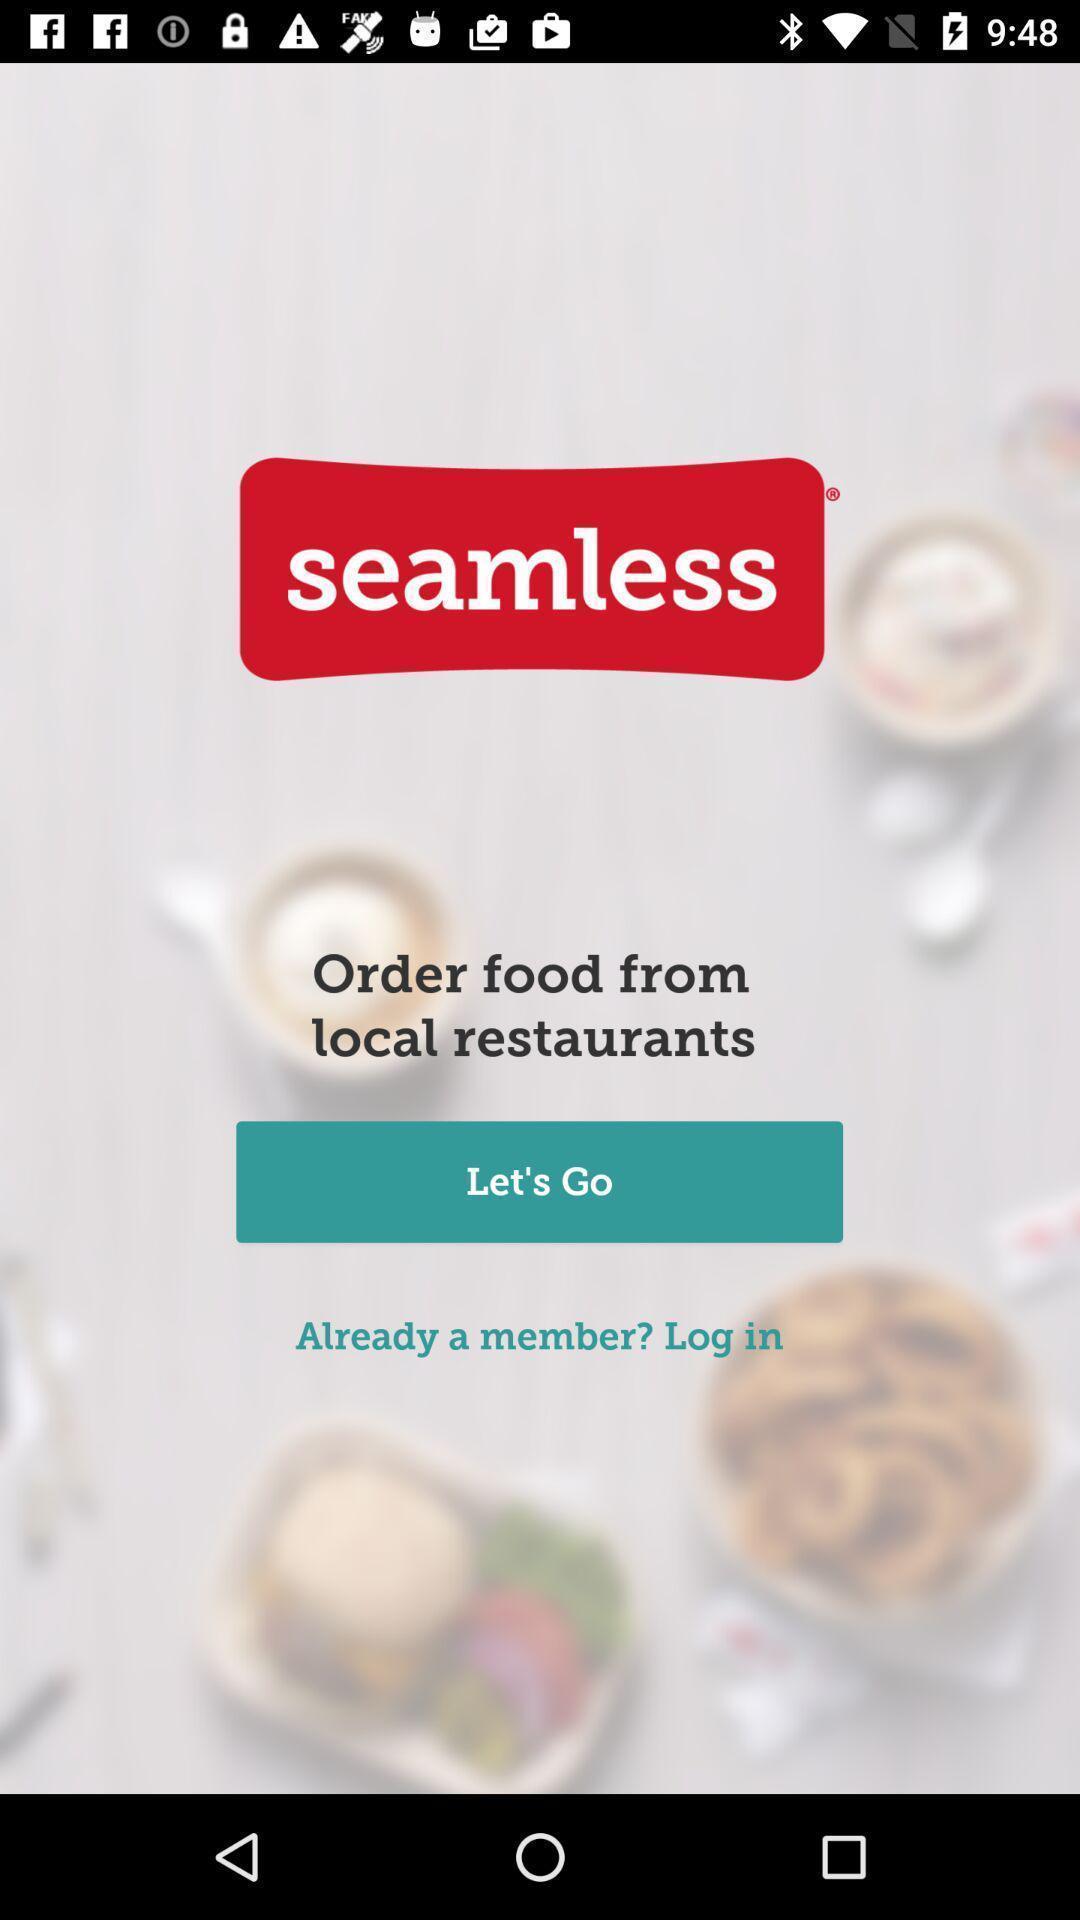Summarize the information in this screenshot. Welcome page of a restaurant food booking app. 